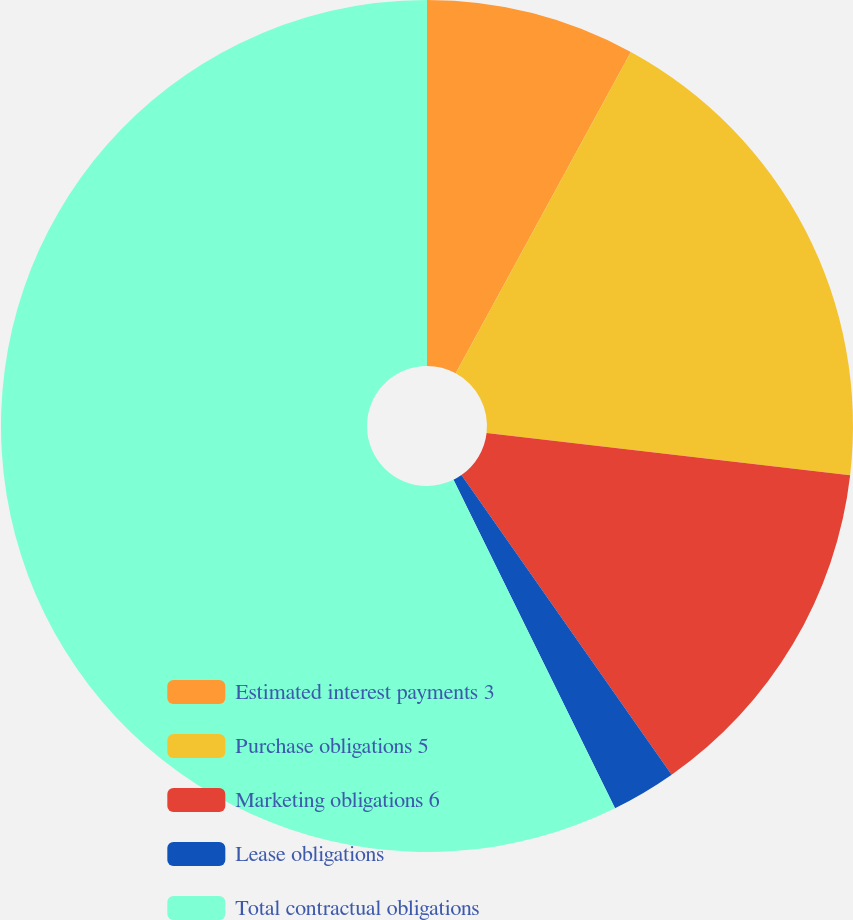Convert chart to OTSL. <chart><loc_0><loc_0><loc_500><loc_500><pie_chart><fcel>Estimated interest payments 3<fcel>Purchase obligations 5<fcel>Marketing obligations 6<fcel>Lease obligations<fcel>Total contractual obligations<nl><fcel>7.94%<fcel>18.9%<fcel>13.42%<fcel>2.46%<fcel>57.27%<nl></chart> 